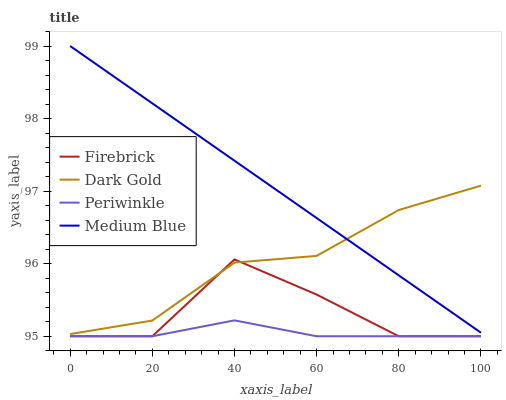Does Periwinkle have the minimum area under the curve?
Answer yes or no. Yes. Does Medium Blue have the maximum area under the curve?
Answer yes or no. Yes. Does Firebrick have the minimum area under the curve?
Answer yes or no. No. Does Firebrick have the maximum area under the curve?
Answer yes or no. No. Is Medium Blue the smoothest?
Answer yes or no. Yes. Is Firebrick the roughest?
Answer yes or no. Yes. Is Periwinkle the smoothest?
Answer yes or no. No. Is Periwinkle the roughest?
Answer yes or no. No. Does Firebrick have the lowest value?
Answer yes or no. Yes. Does Dark Gold have the lowest value?
Answer yes or no. No. Does Medium Blue have the highest value?
Answer yes or no. Yes. Does Firebrick have the highest value?
Answer yes or no. No. Is Periwinkle less than Dark Gold?
Answer yes or no. Yes. Is Medium Blue greater than Periwinkle?
Answer yes or no. Yes. Does Dark Gold intersect Firebrick?
Answer yes or no. Yes. Is Dark Gold less than Firebrick?
Answer yes or no. No. Is Dark Gold greater than Firebrick?
Answer yes or no. No. Does Periwinkle intersect Dark Gold?
Answer yes or no. No. 